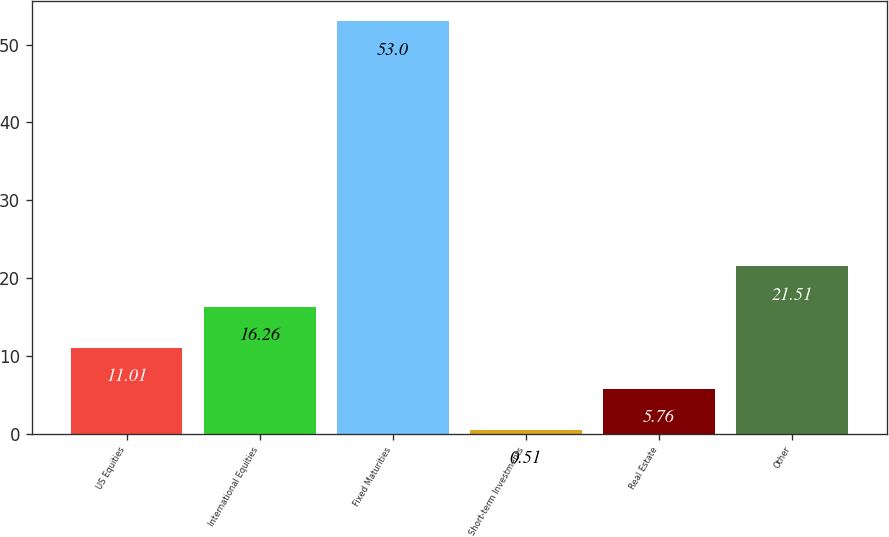Convert chart. <chart><loc_0><loc_0><loc_500><loc_500><bar_chart><fcel>US Equities<fcel>International Equities<fcel>Fixed Maturities<fcel>Short-term Investments<fcel>Real Estate<fcel>Other<nl><fcel>11.01<fcel>16.26<fcel>53<fcel>0.51<fcel>5.76<fcel>21.51<nl></chart> 